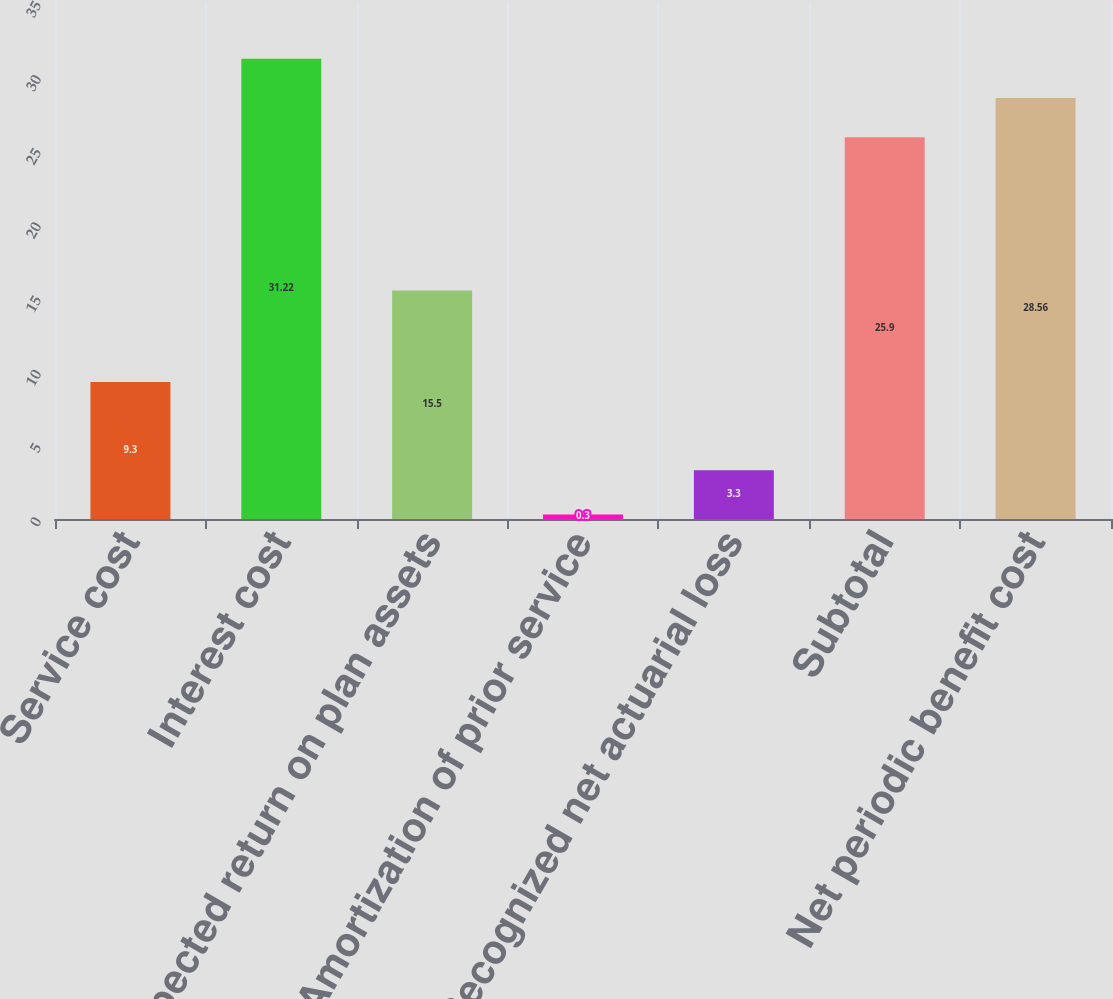Convert chart. <chart><loc_0><loc_0><loc_500><loc_500><bar_chart><fcel>Service cost<fcel>Interest cost<fcel>Expected return on plan assets<fcel>Amortization of prior service<fcel>Recognized net actuarial loss<fcel>Subtotal<fcel>Net periodic benefit cost<nl><fcel>9.3<fcel>31.22<fcel>15.5<fcel>0.3<fcel>3.3<fcel>25.9<fcel>28.56<nl></chart> 